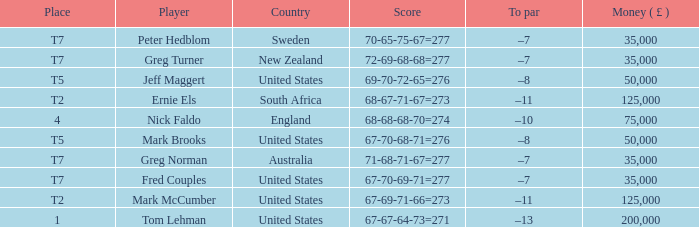What is the highest Money ( £ ), when Player is "Peter Hedblom"? 35000.0. 